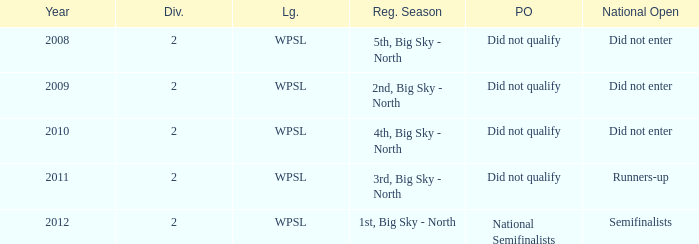What league was involved in 2010? WPSL. 